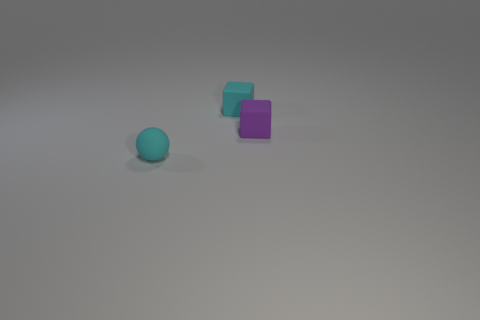Add 2 small purple blocks. How many objects exist? 5 Subtract all spheres. How many objects are left? 2 Add 2 small matte objects. How many small matte objects exist? 5 Subtract 0 purple cylinders. How many objects are left? 3 Subtract all small purple things. Subtract all small purple objects. How many objects are left? 1 Add 2 cyan rubber spheres. How many cyan rubber spheres are left? 3 